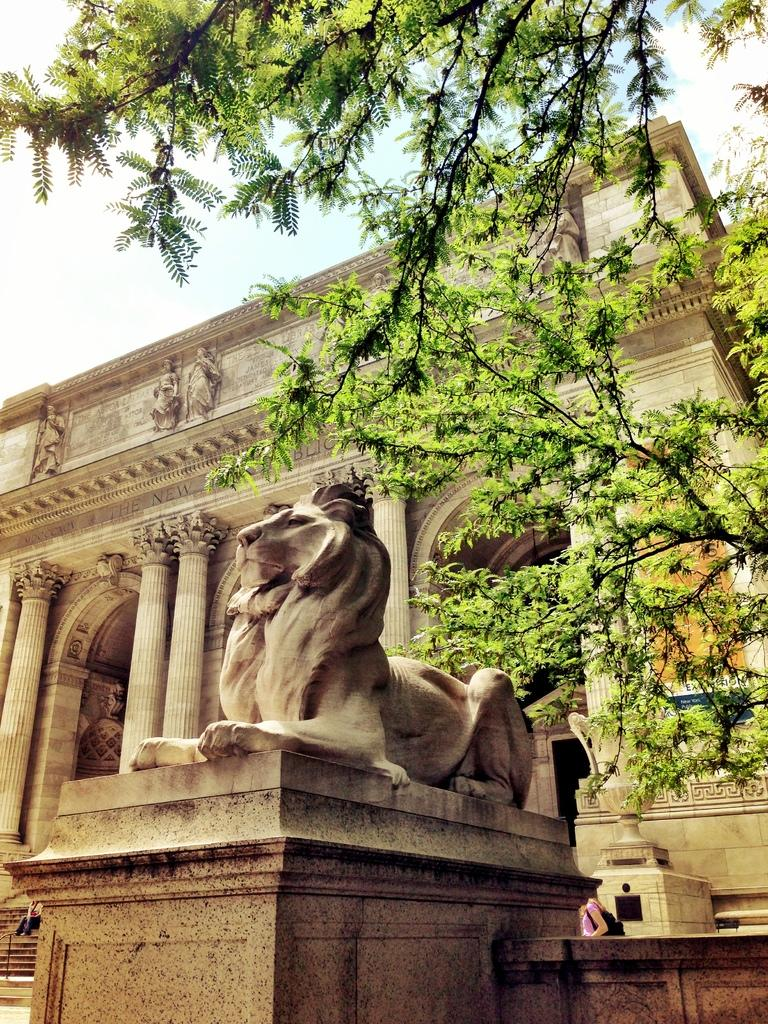What is the main subject in the center of the image? There is a statue in the center of the image. What can be seen in the background of the image? There is a tree, a building, and the sky visible in the background of the image. What type of sticks are being used for learning in the image? There are no sticks or any indication of learning present in the image. 